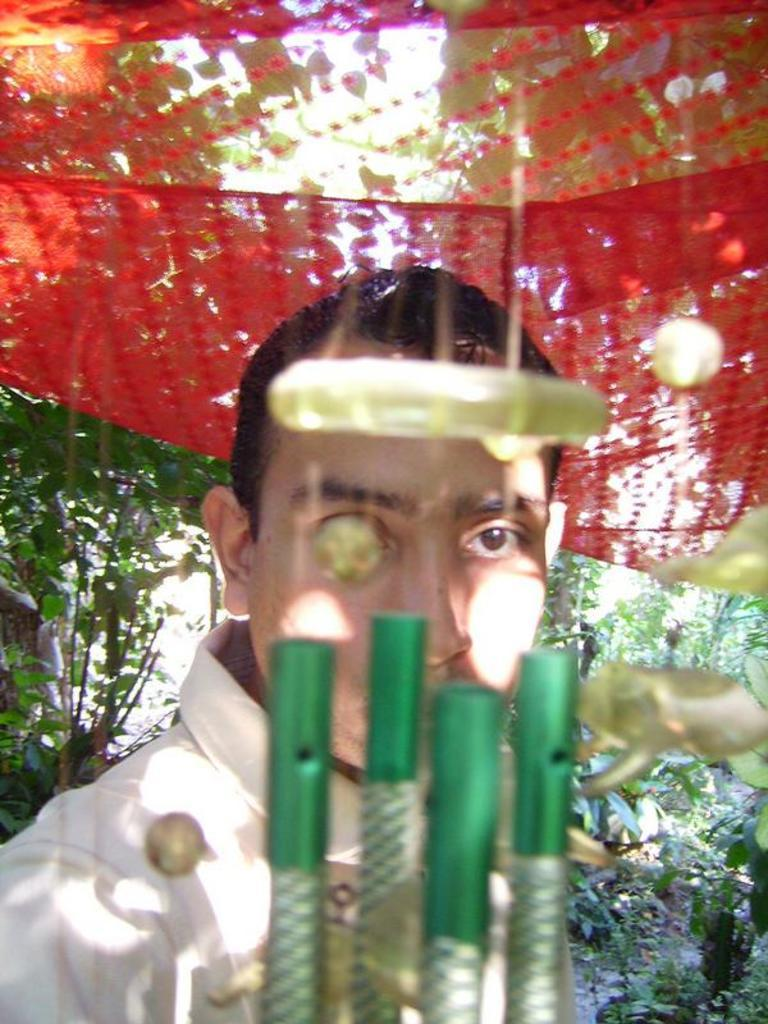What is the main subject of the image? There is a person in the image. What is the person doing in the image? The person is staring at wind chimes. What can be seen in the background of the image? There are trees visible behind the person. What type of heart-shaped object can be seen in the image? There is no heart-shaped object present in the image. How many quarters are visible in the image? There are no quarters visible in the image. 